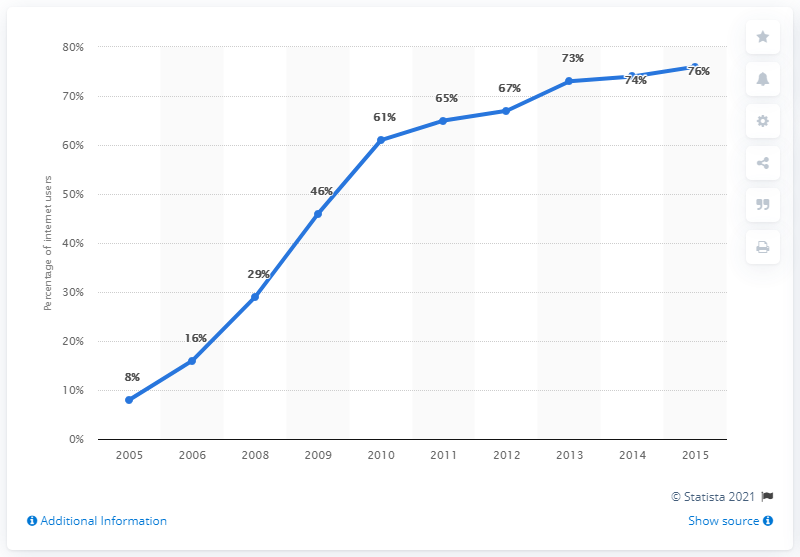Mention a couple of crucial points in this snapshot. In the year 0.08, there were relatively few adult users compared to other years. The peak year for adult users of a particular topic was 2015. 